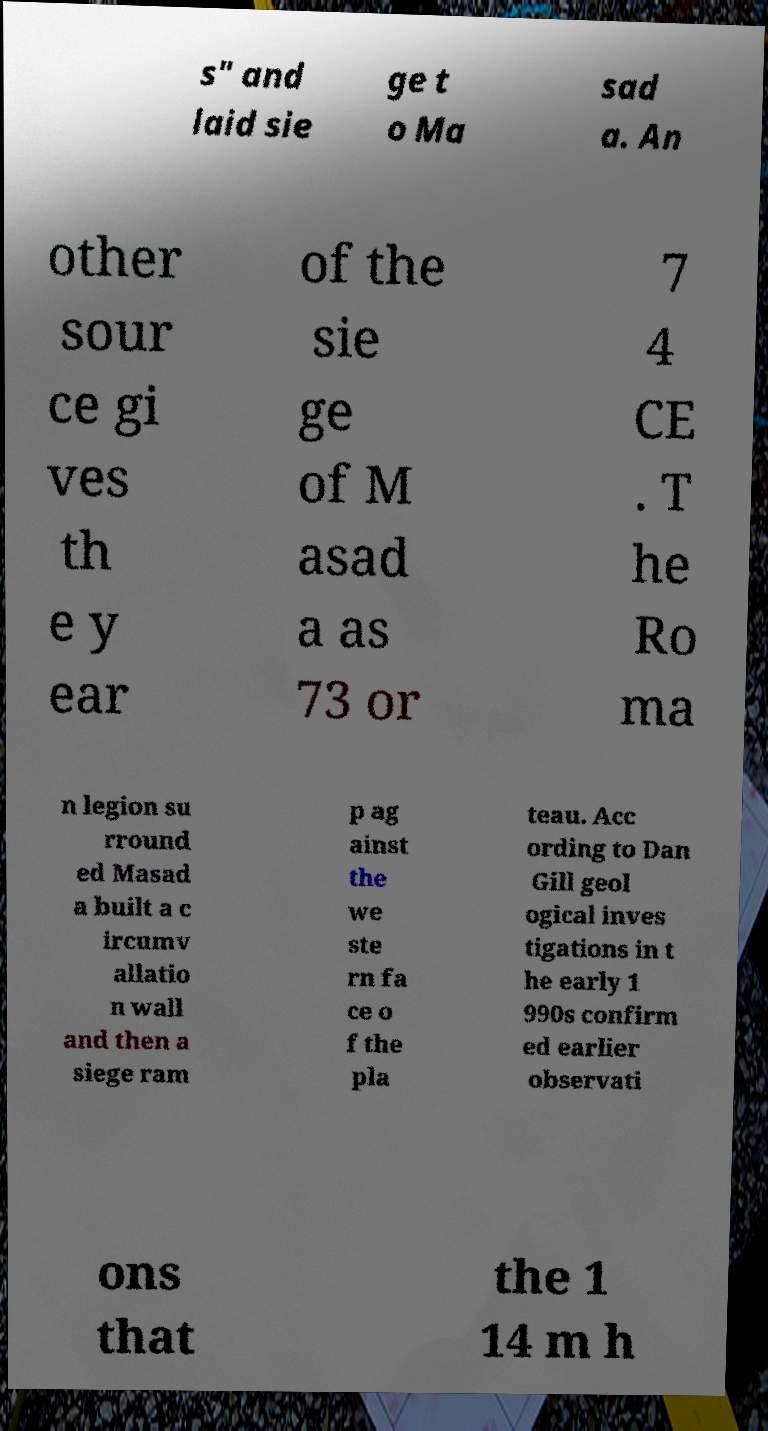What messages or text are displayed in this image? I need them in a readable, typed format. s" and laid sie ge t o Ma sad a. An other sour ce gi ves th e y ear of the sie ge of M asad a as 73 or 7 4 CE . T he Ro ma n legion su rround ed Masad a built a c ircumv allatio n wall and then a siege ram p ag ainst the we ste rn fa ce o f the pla teau. Acc ording to Dan Gill geol ogical inves tigations in t he early 1 990s confirm ed earlier observati ons that the 1 14 m h 